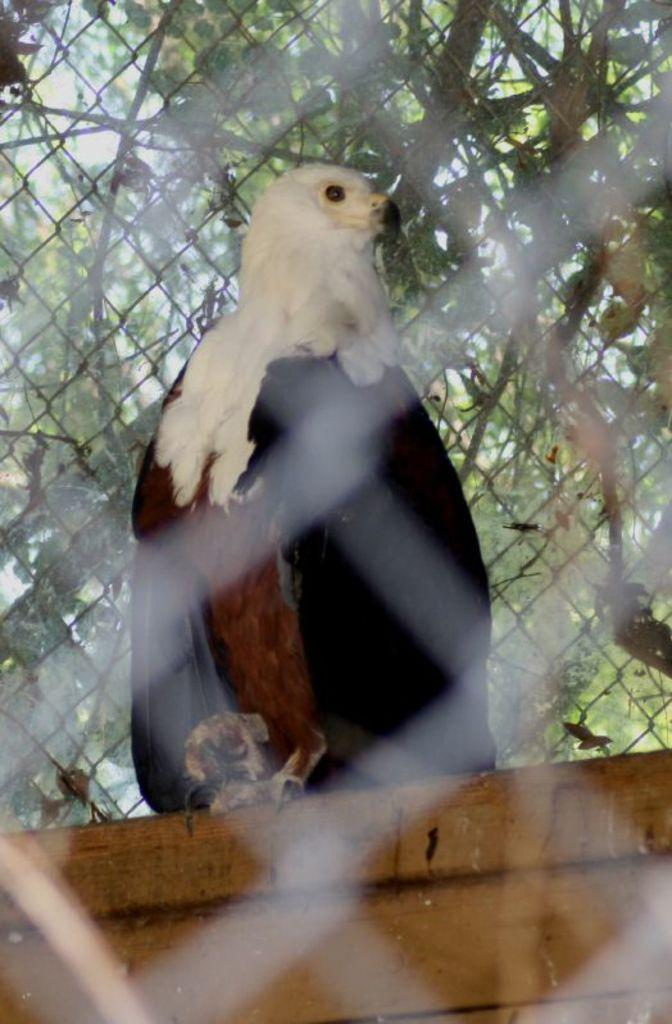What animal is the main subject of the image? There is a vulture in the image. What is the vulture standing on? The vulture is on a wooden block. What can be seen in the background of the image? There are trees in the background of the image. What is the oven's temperature in the image? There is no oven present in the image, so it is not possible to determine its temperature. 